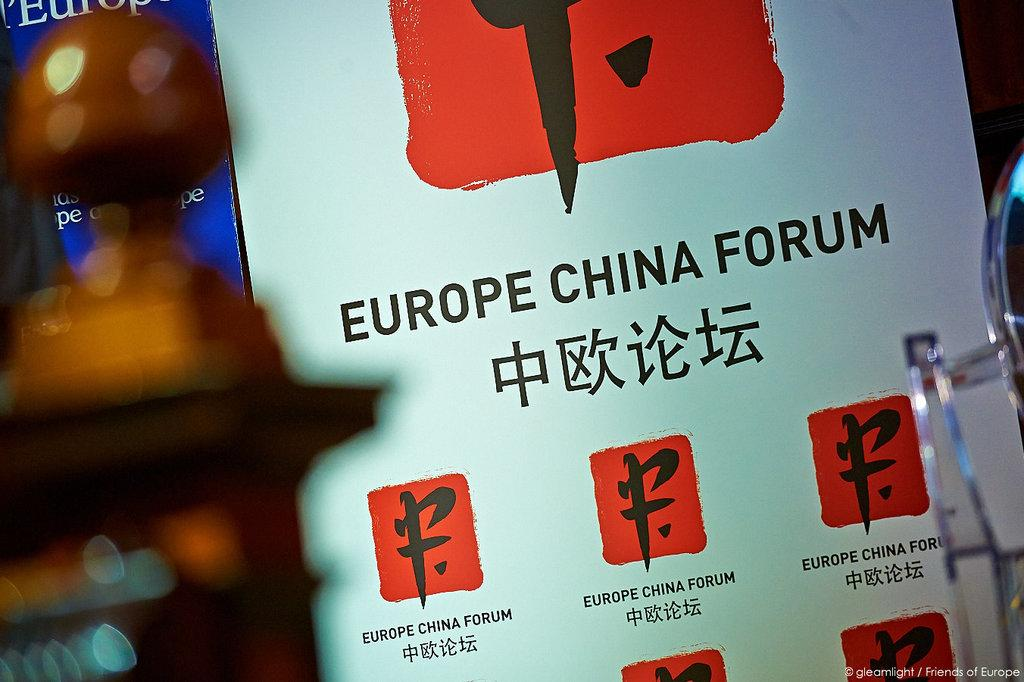Provide a one-sentence caption for the provided image. A white billboard with red and black symbols on it displays a notice that you are at the Europe China Forum. 